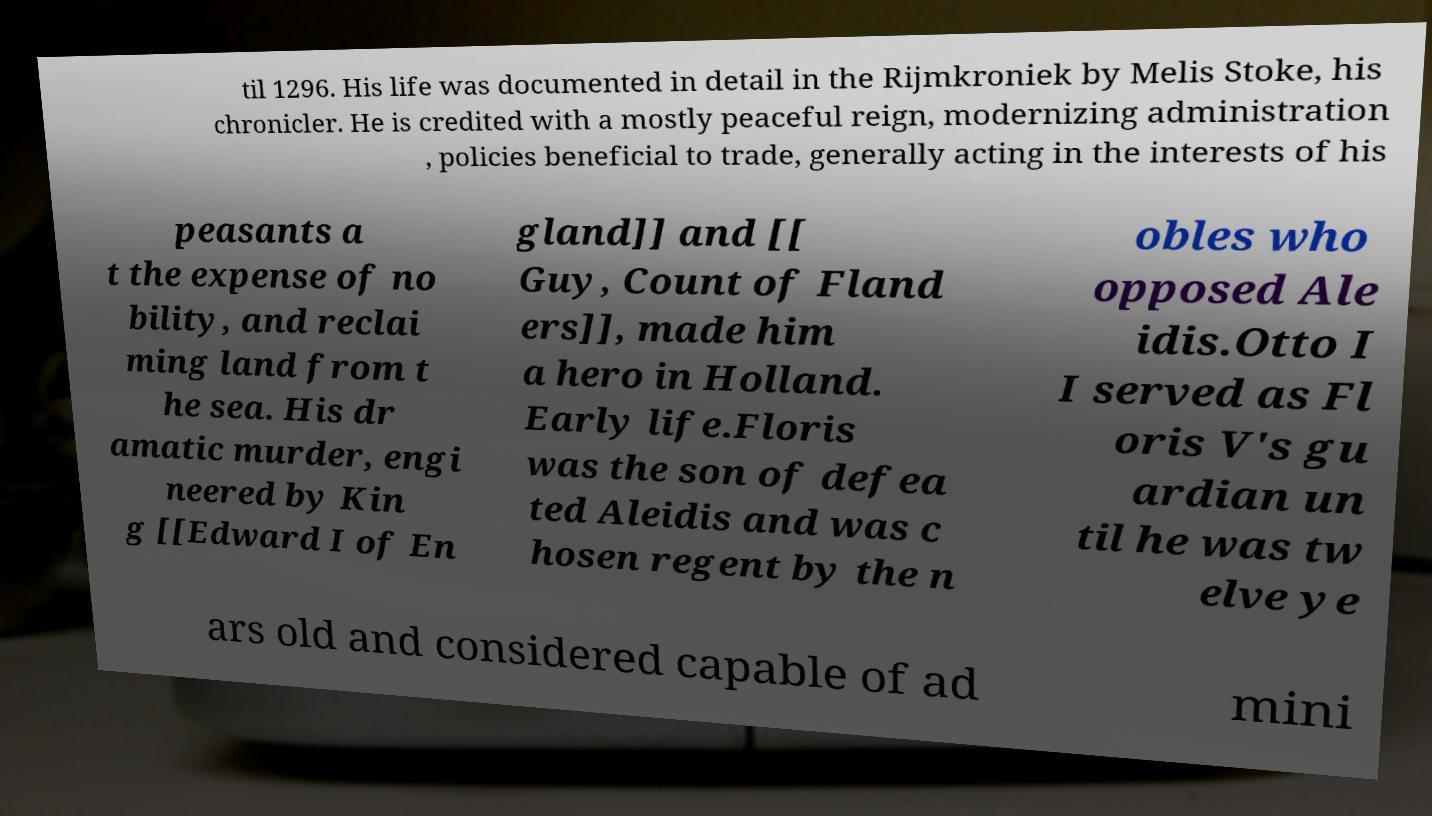Could you assist in decoding the text presented in this image and type it out clearly? til 1296. His life was documented in detail in the Rijmkroniek by Melis Stoke, his chronicler. He is credited with a mostly peaceful reign, modernizing administration , policies beneficial to trade, generally acting in the interests of his peasants a t the expense of no bility, and reclai ming land from t he sea. His dr amatic murder, engi neered by Kin g [[Edward I of En gland]] and [[ Guy, Count of Fland ers]], made him a hero in Holland. Early life.Floris was the son of defea ted Aleidis and was c hosen regent by the n obles who opposed Ale idis.Otto I I served as Fl oris V's gu ardian un til he was tw elve ye ars old and considered capable of ad mini 